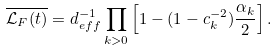Convert formula to latex. <formula><loc_0><loc_0><loc_500><loc_500>\overline { \mathcal { L } _ { F } ( t ) } = d _ { e f f } ^ { - 1 } \prod _ { k > 0 } \left [ 1 - ( 1 - c _ { k } ^ { - 2 } ) \frac { \alpha _ { k } } { 2 } \right ] .</formula> 